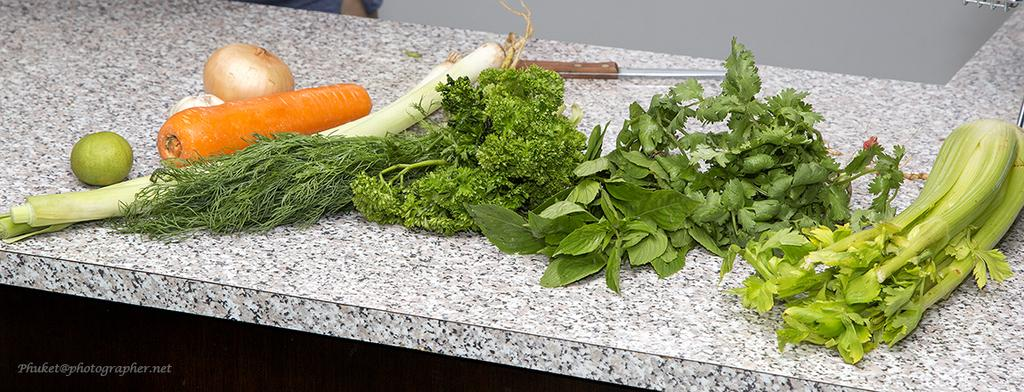What type of food items are present in the image? There are vegetables in the image. What object can be seen on the table in the image? There is a knife on the table in the image. Can you describe any additional features of the image? There is a watermark on the image. What shape is the door in the image? There is no door present in the image; it only features vegetables and a knife on a table. 